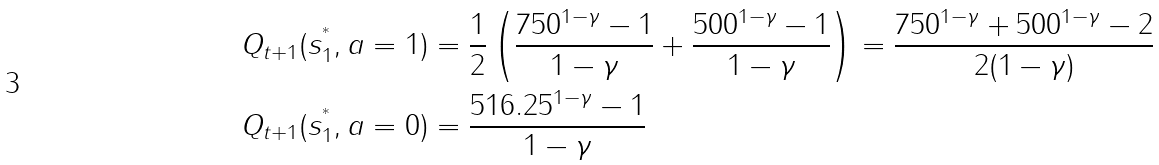<formula> <loc_0><loc_0><loc_500><loc_500>Q _ { t + 1 } ( s _ { 1 } ^ { ^ { * } } , a = 1 ) & = \frac { 1 } { 2 } \left ( \frac { 7 5 0 ^ { 1 - \gamma } - 1 } { 1 - \gamma } + \frac { 5 0 0 ^ { 1 - \gamma } - 1 } { 1 - \gamma } \right ) = \frac { 7 5 0 ^ { 1 - \gamma } + 5 0 0 ^ { 1 - \gamma } - 2 } { 2 ( 1 - \gamma ) } \\ Q _ { t + 1 } ( s _ { 1 } ^ { ^ { * } } , a = 0 ) & = \frac { 5 1 6 . 2 5 ^ { 1 - \gamma } - 1 } { 1 - \gamma }</formula> 